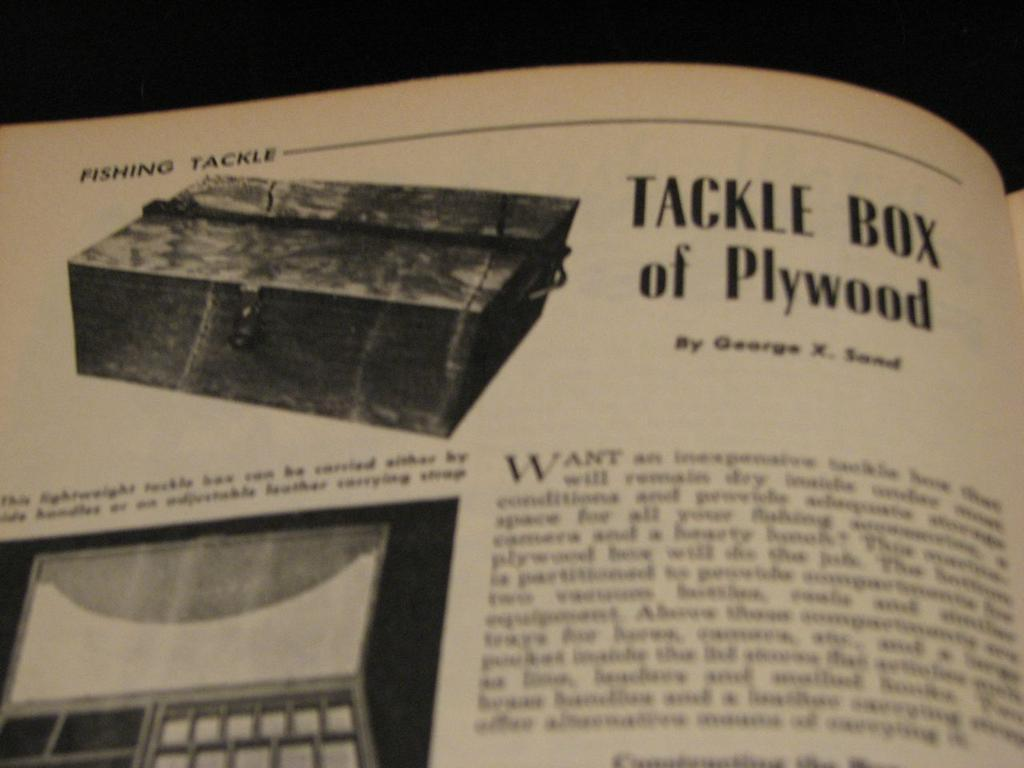<image>
Share a concise interpretation of the image provided. Vintage catalog with a wooden box labeled Tackle Box of Plywood. 